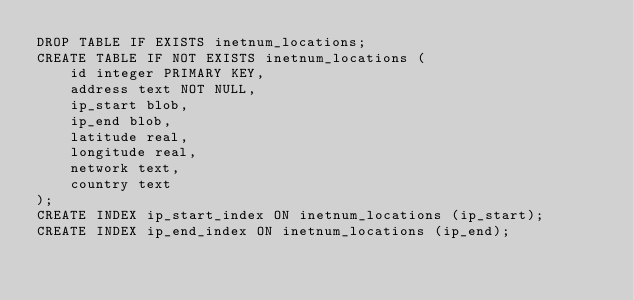Convert code to text. <code><loc_0><loc_0><loc_500><loc_500><_SQL_>DROP TABLE IF EXISTS inetnum_locations;
CREATE TABLE IF NOT EXISTS inetnum_locations (
    id integer PRIMARY KEY,
    address text NOT NULL,
    ip_start blob,
    ip_end blob,
    latitude real,
    longitude real,
    network text,
    country text
);
CREATE INDEX ip_start_index ON inetnum_locations (ip_start);
CREATE INDEX ip_end_index ON inetnum_locations (ip_end);</code> 